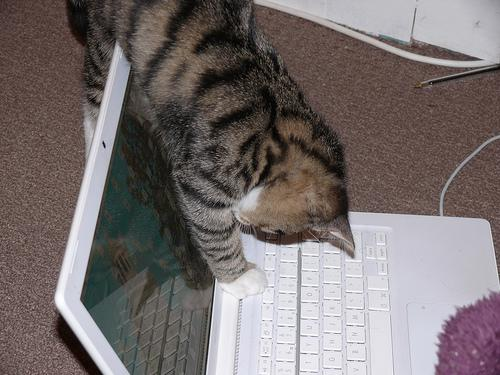Question: what is the animal in the picture?
Choices:
A. Cat.
B. Dog.
C. Bird.
D. Horse.
Answer with the letter. Answer: A Question: how is the cat looking at the laptop screen?
Choices:
A. At the side.
B. It's directly in front of him.
C. From behind.
D. Upside down.
Answer with the letter. Answer: D Question: what color is the carpet?
Choices:
A. Brown.
B. Yellow.
C. White.
D. Tan.
Answer with the letter. Answer: D Question: what is located at the top right of the photo on the floor?
Choices:
A. Doll.
B. Ball.
C. Pen.
D. Notebook.
Answer with the letter. Answer: C Question: what is the animal standing on?
Choices:
A. Suitcase.
B. Table.
C. Couch.
D. Laptop.
Answer with the letter. Answer: D 